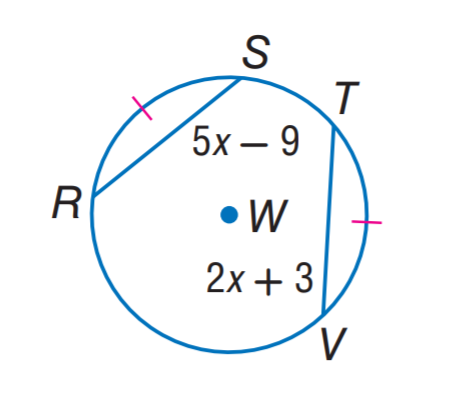Question: In \odot W, \widehat R S \cong \widehat T V. Find R S.
Choices:
A. 9
B. 11
C. 13
D. 22
Answer with the letter. Answer: B 